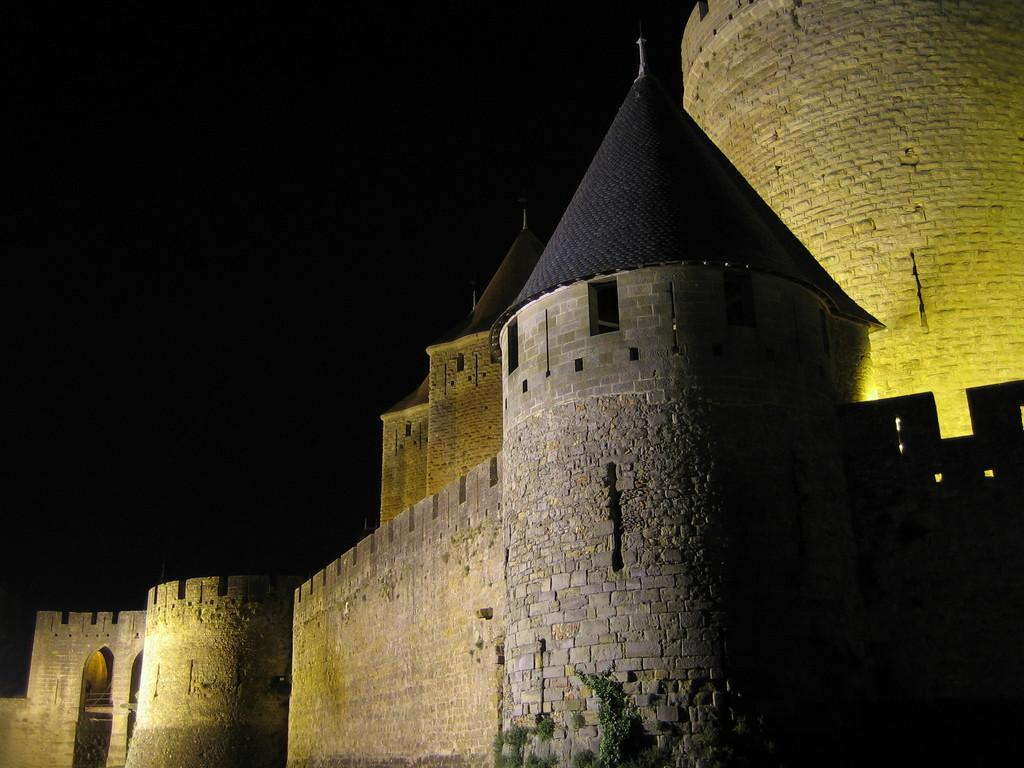What is the main subject of the image? There is a castle in the image. Can you describe the background of the image? The background of the image is dark. What type of thread is being used to play chess in the image? There is no chess game or thread present in the image; it features a castle with a dark background. 